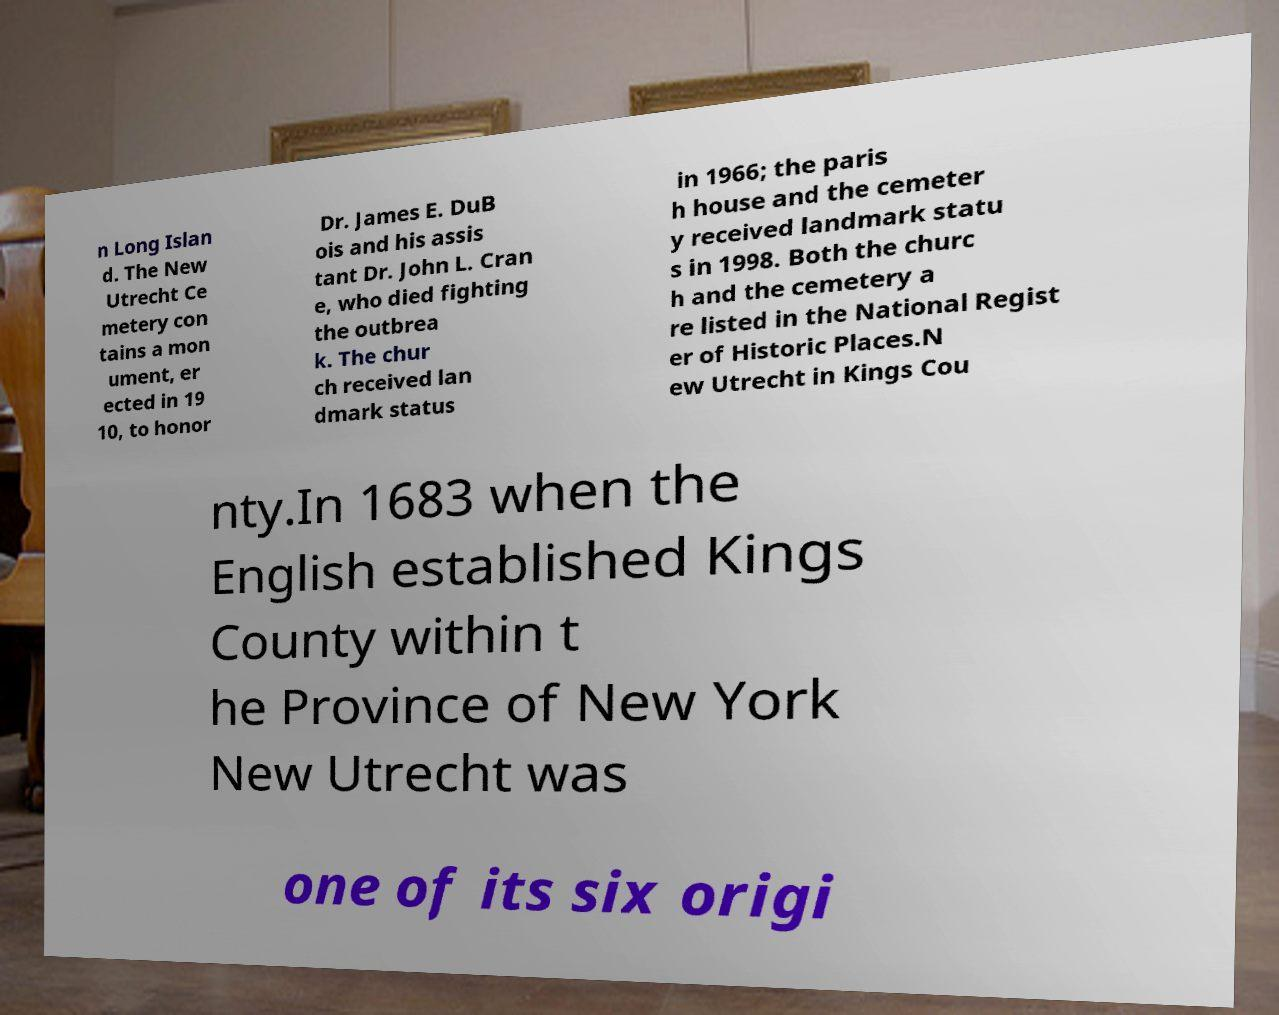Could you assist in decoding the text presented in this image and type it out clearly? n Long Islan d. The New Utrecht Ce metery con tains a mon ument, er ected in 19 10, to honor Dr. James E. DuB ois and his assis tant Dr. John L. Cran e, who died fighting the outbrea k. The chur ch received lan dmark status in 1966; the paris h house and the cemeter y received landmark statu s in 1998. Both the churc h and the cemetery a re listed in the National Regist er of Historic Places.N ew Utrecht in Kings Cou nty.In 1683 when the English established Kings County within t he Province of New York New Utrecht was one of its six origi 